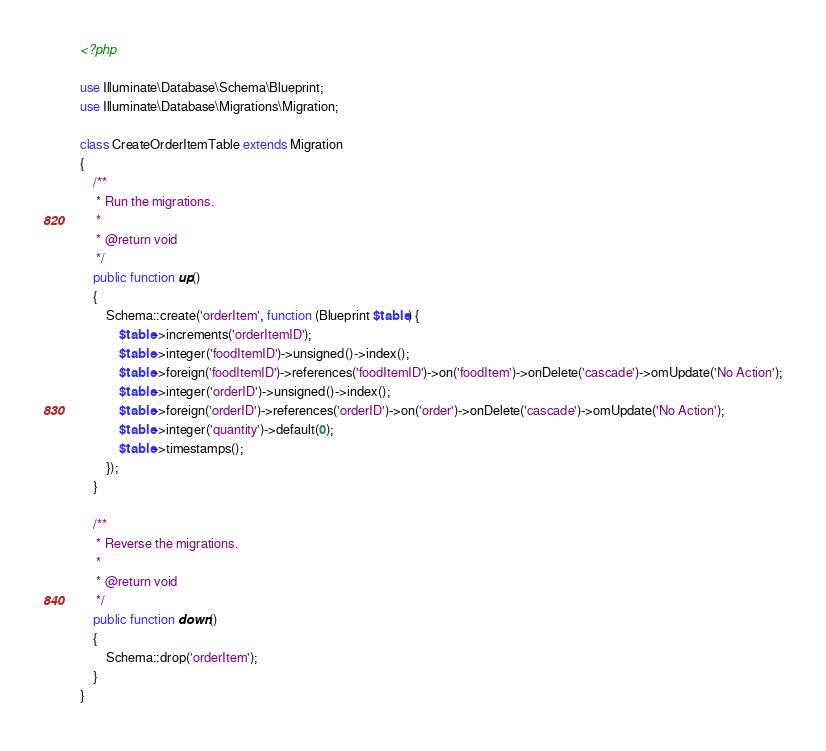<code> <loc_0><loc_0><loc_500><loc_500><_PHP_><?php

use Illuminate\Database\Schema\Blueprint;
use Illuminate\Database\Migrations\Migration;

class CreateOrderItemTable extends Migration
{
    /**
     * Run the migrations.
     *
     * @return void
     */
    public function up()
    {
        Schema::create('orderItem', function (Blueprint $table) {
            $table->increments('orderItemID');
            $table->integer('foodItemID')->unsigned()->index();
            $table->foreign('foodItemID')->references('foodItemID')->on('foodItem')->onDelete('cascade')->omUpdate('No Action');
            $table->integer('orderID')->unsigned()->index();
            $table->foreign('orderID')->references('orderID')->on('order')->onDelete('cascade')->omUpdate('No Action');
            $table->integer('quantity')->default(0);
            $table->timestamps();
        });
    }

    /**
     * Reverse the migrations.
     *
     * @return void
     */
    public function down()
    {
        Schema::drop('orderItem');
    }
}
</code> 